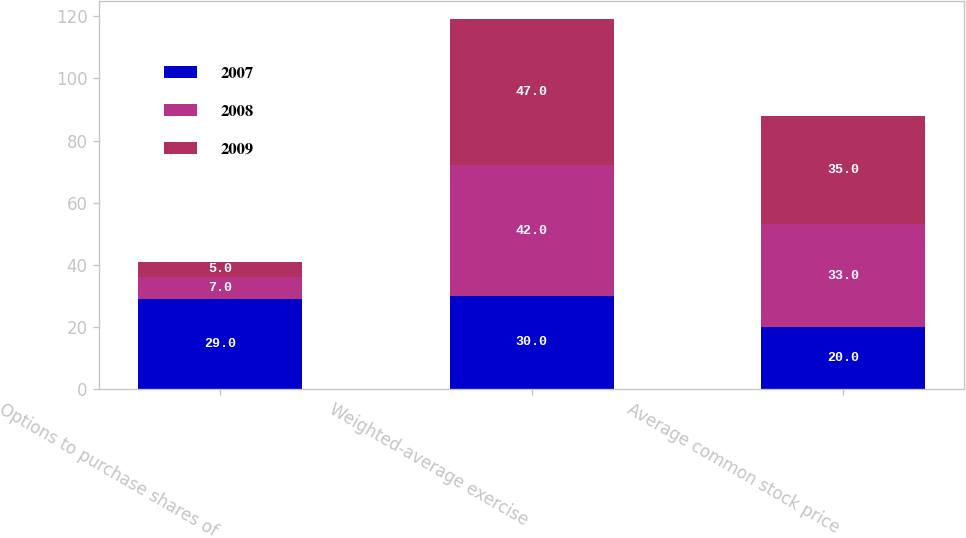Convert chart to OTSL. <chart><loc_0><loc_0><loc_500><loc_500><stacked_bar_chart><ecel><fcel>Options to purchase shares of<fcel>Weighted-average exercise<fcel>Average common stock price<nl><fcel>2007<fcel>29<fcel>30<fcel>20<nl><fcel>2008<fcel>7<fcel>42<fcel>33<nl><fcel>2009<fcel>5<fcel>47<fcel>35<nl></chart> 